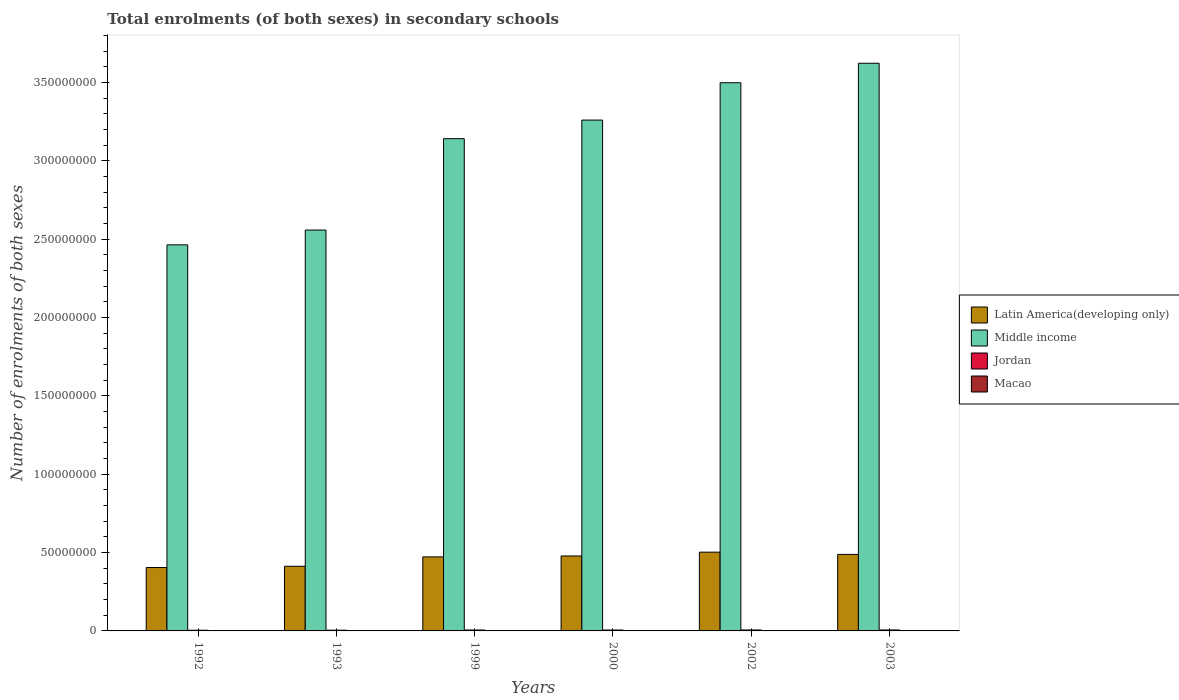How many different coloured bars are there?
Your response must be concise. 4. How many groups of bars are there?
Give a very brief answer. 6. Are the number of bars on each tick of the X-axis equal?
Make the answer very short. Yes. How many bars are there on the 2nd tick from the left?
Keep it short and to the point. 4. How many bars are there on the 4th tick from the right?
Ensure brevity in your answer.  4. In how many cases, is the number of bars for a given year not equal to the number of legend labels?
Make the answer very short. 0. What is the number of enrolments in secondary schools in Jordan in 1992?
Your answer should be very brief. 4.39e+05. Across all years, what is the maximum number of enrolments in secondary schools in Jordan?
Provide a succinct answer. 6.13e+05. Across all years, what is the minimum number of enrolments in secondary schools in Latin America(developing only)?
Offer a very short reply. 4.04e+07. What is the total number of enrolments in secondary schools in Latin America(developing only) in the graph?
Provide a succinct answer. 2.76e+08. What is the difference between the number of enrolments in secondary schools in Jordan in 1999 and that in 2002?
Provide a short and direct response. -2.72e+04. What is the difference between the number of enrolments in secondary schools in Latin America(developing only) in 1993 and the number of enrolments in secondary schools in Middle income in 2002?
Make the answer very short. -3.09e+08. What is the average number of enrolments in secondary schools in Macao per year?
Give a very brief answer. 3.22e+04. In the year 1992, what is the difference between the number of enrolments in secondary schools in Macao and number of enrolments in secondary schools in Middle income?
Offer a very short reply. -2.46e+08. In how many years, is the number of enrolments in secondary schools in Latin America(developing only) greater than 340000000?
Your answer should be compact. 0. What is the ratio of the number of enrolments in secondary schools in Macao in 1992 to that in 2002?
Your answer should be compact. 0.45. What is the difference between the highest and the second highest number of enrolments in secondary schools in Jordan?
Your answer should be compact. 6505. What is the difference between the highest and the lowest number of enrolments in secondary schools in Jordan?
Offer a very short reply. 1.74e+05. What does the 2nd bar from the left in 1999 represents?
Make the answer very short. Middle income. What does the 4th bar from the right in 1992 represents?
Keep it short and to the point. Latin America(developing only). Is it the case that in every year, the sum of the number of enrolments in secondary schools in Middle income and number of enrolments in secondary schools in Latin America(developing only) is greater than the number of enrolments in secondary schools in Macao?
Ensure brevity in your answer.  Yes. How many bars are there?
Provide a succinct answer. 24. Are all the bars in the graph horizontal?
Your answer should be compact. No. Where does the legend appear in the graph?
Offer a terse response. Center right. How many legend labels are there?
Give a very brief answer. 4. How are the legend labels stacked?
Keep it short and to the point. Vertical. What is the title of the graph?
Offer a very short reply. Total enrolments (of both sexes) in secondary schools. What is the label or title of the X-axis?
Provide a short and direct response. Years. What is the label or title of the Y-axis?
Your answer should be compact. Number of enrolments of both sexes. What is the Number of enrolments of both sexes of Latin America(developing only) in 1992?
Make the answer very short. 4.04e+07. What is the Number of enrolments of both sexes of Middle income in 1992?
Keep it short and to the point. 2.46e+08. What is the Number of enrolments of both sexes in Jordan in 1992?
Offer a terse response. 4.39e+05. What is the Number of enrolments of both sexes of Macao in 1992?
Your answer should be very brief. 1.90e+04. What is the Number of enrolments of both sexes in Latin America(developing only) in 1993?
Offer a very short reply. 4.13e+07. What is the Number of enrolments of both sexes in Middle income in 1993?
Keep it short and to the point. 2.56e+08. What is the Number of enrolments of both sexes in Jordan in 1993?
Offer a very short reply. 4.58e+05. What is the Number of enrolments of both sexes in Macao in 1993?
Your answer should be compact. 2.04e+04. What is the Number of enrolments of both sexes of Latin America(developing only) in 1999?
Keep it short and to the point. 4.72e+07. What is the Number of enrolments of both sexes in Middle income in 1999?
Your answer should be very brief. 3.14e+08. What is the Number of enrolments of both sexes in Jordan in 1999?
Your response must be concise. 5.79e+05. What is the Number of enrolments of both sexes in Macao in 1999?
Provide a short and direct response. 3.19e+04. What is the Number of enrolments of both sexes of Latin America(developing only) in 2000?
Ensure brevity in your answer.  4.78e+07. What is the Number of enrolments of both sexes of Middle income in 2000?
Your response must be concise. 3.26e+08. What is the Number of enrolments of both sexes in Jordan in 2000?
Make the answer very short. 5.84e+05. What is the Number of enrolments of both sexes in Macao in 2000?
Keep it short and to the point. 3.54e+04. What is the Number of enrolments of both sexes of Latin America(developing only) in 2002?
Ensure brevity in your answer.  5.03e+07. What is the Number of enrolments of both sexes in Middle income in 2002?
Offer a very short reply. 3.50e+08. What is the Number of enrolments of both sexes of Jordan in 2002?
Provide a succinct answer. 6.07e+05. What is the Number of enrolments of both sexes of Macao in 2002?
Provide a succinct answer. 4.20e+04. What is the Number of enrolments of both sexes of Latin America(developing only) in 2003?
Make the answer very short. 4.88e+07. What is the Number of enrolments of both sexes of Middle income in 2003?
Your response must be concise. 3.62e+08. What is the Number of enrolments of both sexes in Jordan in 2003?
Ensure brevity in your answer.  6.13e+05. What is the Number of enrolments of both sexes in Macao in 2003?
Offer a terse response. 4.44e+04. Across all years, what is the maximum Number of enrolments of both sexes of Latin America(developing only)?
Offer a very short reply. 5.03e+07. Across all years, what is the maximum Number of enrolments of both sexes of Middle income?
Your response must be concise. 3.62e+08. Across all years, what is the maximum Number of enrolments of both sexes in Jordan?
Offer a terse response. 6.13e+05. Across all years, what is the maximum Number of enrolments of both sexes in Macao?
Ensure brevity in your answer.  4.44e+04. Across all years, what is the minimum Number of enrolments of both sexes of Latin America(developing only)?
Keep it short and to the point. 4.04e+07. Across all years, what is the minimum Number of enrolments of both sexes in Middle income?
Keep it short and to the point. 2.46e+08. Across all years, what is the minimum Number of enrolments of both sexes in Jordan?
Offer a terse response. 4.39e+05. Across all years, what is the minimum Number of enrolments of both sexes of Macao?
Your answer should be compact. 1.90e+04. What is the total Number of enrolments of both sexes of Latin America(developing only) in the graph?
Give a very brief answer. 2.76e+08. What is the total Number of enrolments of both sexes in Middle income in the graph?
Offer a terse response. 1.85e+09. What is the total Number of enrolments of both sexes of Jordan in the graph?
Ensure brevity in your answer.  3.28e+06. What is the total Number of enrolments of both sexes of Macao in the graph?
Offer a very short reply. 1.93e+05. What is the difference between the Number of enrolments of both sexes in Latin America(developing only) in 1992 and that in 1993?
Your response must be concise. -8.00e+05. What is the difference between the Number of enrolments of both sexes of Middle income in 1992 and that in 1993?
Provide a short and direct response. -9.45e+06. What is the difference between the Number of enrolments of both sexes in Jordan in 1992 and that in 1993?
Your response must be concise. -1.95e+04. What is the difference between the Number of enrolments of both sexes of Macao in 1992 and that in 1993?
Your answer should be compact. -1405. What is the difference between the Number of enrolments of both sexes of Latin America(developing only) in 1992 and that in 1999?
Ensure brevity in your answer.  -6.79e+06. What is the difference between the Number of enrolments of both sexes of Middle income in 1992 and that in 1999?
Ensure brevity in your answer.  -6.78e+07. What is the difference between the Number of enrolments of both sexes in Jordan in 1992 and that in 1999?
Offer a very short reply. -1.41e+05. What is the difference between the Number of enrolments of both sexes in Macao in 1992 and that in 1999?
Offer a terse response. -1.29e+04. What is the difference between the Number of enrolments of both sexes of Latin America(developing only) in 1992 and that in 2000?
Offer a terse response. -7.37e+06. What is the difference between the Number of enrolments of both sexes in Middle income in 1992 and that in 2000?
Your answer should be very brief. -7.96e+07. What is the difference between the Number of enrolments of both sexes of Jordan in 1992 and that in 2000?
Keep it short and to the point. -1.45e+05. What is the difference between the Number of enrolments of both sexes in Macao in 1992 and that in 2000?
Your answer should be very brief. -1.64e+04. What is the difference between the Number of enrolments of both sexes of Latin America(developing only) in 1992 and that in 2002?
Offer a terse response. -9.80e+06. What is the difference between the Number of enrolments of both sexes of Middle income in 1992 and that in 2002?
Your answer should be compact. -1.03e+08. What is the difference between the Number of enrolments of both sexes of Jordan in 1992 and that in 2002?
Your answer should be very brief. -1.68e+05. What is the difference between the Number of enrolments of both sexes of Macao in 1992 and that in 2002?
Keep it short and to the point. -2.30e+04. What is the difference between the Number of enrolments of both sexes of Latin America(developing only) in 1992 and that in 2003?
Make the answer very short. -8.37e+06. What is the difference between the Number of enrolments of both sexes in Middle income in 1992 and that in 2003?
Ensure brevity in your answer.  -1.16e+08. What is the difference between the Number of enrolments of both sexes of Jordan in 1992 and that in 2003?
Provide a succinct answer. -1.74e+05. What is the difference between the Number of enrolments of both sexes in Macao in 1992 and that in 2003?
Ensure brevity in your answer.  -2.54e+04. What is the difference between the Number of enrolments of both sexes in Latin America(developing only) in 1993 and that in 1999?
Offer a very short reply. -5.99e+06. What is the difference between the Number of enrolments of both sexes in Middle income in 1993 and that in 1999?
Provide a short and direct response. -5.83e+07. What is the difference between the Number of enrolments of both sexes in Jordan in 1993 and that in 1999?
Your answer should be compact. -1.21e+05. What is the difference between the Number of enrolments of both sexes in Macao in 1993 and that in 1999?
Your answer should be very brief. -1.15e+04. What is the difference between the Number of enrolments of both sexes in Latin America(developing only) in 1993 and that in 2000?
Make the answer very short. -6.57e+06. What is the difference between the Number of enrolments of both sexes in Middle income in 1993 and that in 2000?
Your answer should be very brief. -7.02e+07. What is the difference between the Number of enrolments of both sexes of Jordan in 1993 and that in 2000?
Offer a very short reply. -1.25e+05. What is the difference between the Number of enrolments of both sexes of Macao in 1993 and that in 2000?
Provide a short and direct response. -1.50e+04. What is the difference between the Number of enrolments of both sexes in Latin America(developing only) in 1993 and that in 2002?
Offer a terse response. -9.00e+06. What is the difference between the Number of enrolments of both sexes of Middle income in 1993 and that in 2002?
Offer a very short reply. -9.40e+07. What is the difference between the Number of enrolments of both sexes in Jordan in 1993 and that in 2002?
Offer a terse response. -1.48e+05. What is the difference between the Number of enrolments of both sexes in Macao in 1993 and that in 2002?
Your answer should be compact. -2.16e+04. What is the difference between the Number of enrolments of both sexes of Latin America(developing only) in 1993 and that in 2003?
Keep it short and to the point. -7.57e+06. What is the difference between the Number of enrolments of both sexes in Middle income in 1993 and that in 2003?
Provide a short and direct response. -1.06e+08. What is the difference between the Number of enrolments of both sexes of Jordan in 1993 and that in 2003?
Give a very brief answer. -1.55e+05. What is the difference between the Number of enrolments of both sexes in Macao in 1993 and that in 2003?
Your answer should be compact. -2.40e+04. What is the difference between the Number of enrolments of both sexes in Latin America(developing only) in 1999 and that in 2000?
Ensure brevity in your answer.  -5.86e+05. What is the difference between the Number of enrolments of both sexes in Middle income in 1999 and that in 2000?
Ensure brevity in your answer.  -1.19e+07. What is the difference between the Number of enrolments of both sexes of Jordan in 1999 and that in 2000?
Your answer should be compact. -4090. What is the difference between the Number of enrolments of both sexes in Macao in 1999 and that in 2000?
Give a very brief answer. -3508. What is the difference between the Number of enrolments of both sexes of Latin America(developing only) in 1999 and that in 2002?
Offer a terse response. -3.01e+06. What is the difference between the Number of enrolments of both sexes in Middle income in 1999 and that in 2002?
Your answer should be compact. -3.57e+07. What is the difference between the Number of enrolments of both sexes of Jordan in 1999 and that in 2002?
Make the answer very short. -2.72e+04. What is the difference between the Number of enrolments of both sexes in Macao in 1999 and that in 2002?
Your response must be concise. -1.02e+04. What is the difference between the Number of enrolments of both sexes of Latin America(developing only) in 1999 and that in 2003?
Your answer should be very brief. -1.58e+06. What is the difference between the Number of enrolments of both sexes in Middle income in 1999 and that in 2003?
Give a very brief answer. -4.81e+07. What is the difference between the Number of enrolments of both sexes in Jordan in 1999 and that in 2003?
Ensure brevity in your answer.  -3.37e+04. What is the difference between the Number of enrolments of both sexes of Macao in 1999 and that in 2003?
Provide a short and direct response. -1.26e+04. What is the difference between the Number of enrolments of both sexes of Latin America(developing only) in 2000 and that in 2002?
Your answer should be very brief. -2.43e+06. What is the difference between the Number of enrolments of both sexes of Middle income in 2000 and that in 2002?
Your answer should be very brief. -2.38e+07. What is the difference between the Number of enrolments of both sexes of Jordan in 2000 and that in 2002?
Ensure brevity in your answer.  -2.31e+04. What is the difference between the Number of enrolments of both sexes in Macao in 2000 and that in 2002?
Your answer should be very brief. -6650. What is the difference between the Number of enrolments of both sexes of Latin America(developing only) in 2000 and that in 2003?
Offer a terse response. -9.97e+05. What is the difference between the Number of enrolments of both sexes of Middle income in 2000 and that in 2003?
Provide a short and direct response. -3.62e+07. What is the difference between the Number of enrolments of both sexes in Jordan in 2000 and that in 2003?
Offer a very short reply. -2.96e+04. What is the difference between the Number of enrolments of both sexes in Macao in 2000 and that in 2003?
Your answer should be compact. -9058. What is the difference between the Number of enrolments of both sexes of Latin America(developing only) in 2002 and that in 2003?
Your response must be concise. 1.43e+06. What is the difference between the Number of enrolments of both sexes in Middle income in 2002 and that in 2003?
Give a very brief answer. -1.24e+07. What is the difference between the Number of enrolments of both sexes of Jordan in 2002 and that in 2003?
Provide a short and direct response. -6505. What is the difference between the Number of enrolments of both sexes in Macao in 2002 and that in 2003?
Offer a very short reply. -2408. What is the difference between the Number of enrolments of both sexes in Latin America(developing only) in 1992 and the Number of enrolments of both sexes in Middle income in 1993?
Provide a short and direct response. -2.15e+08. What is the difference between the Number of enrolments of both sexes of Latin America(developing only) in 1992 and the Number of enrolments of both sexes of Jordan in 1993?
Keep it short and to the point. 4.00e+07. What is the difference between the Number of enrolments of both sexes of Latin America(developing only) in 1992 and the Number of enrolments of both sexes of Macao in 1993?
Make the answer very short. 4.04e+07. What is the difference between the Number of enrolments of both sexes in Middle income in 1992 and the Number of enrolments of both sexes in Jordan in 1993?
Offer a very short reply. 2.46e+08. What is the difference between the Number of enrolments of both sexes in Middle income in 1992 and the Number of enrolments of both sexes in Macao in 1993?
Make the answer very short. 2.46e+08. What is the difference between the Number of enrolments of both sexes in Jordan in 1992 and the Number of enrolments of both sexes in Macao in 1993?
Your answer should be compact. 4.19e+05. What is the difference between the Number of enrolments of both sexes in Latin America(developing only) in 1992 and the Number of enrolments of both sexes in Middle income in 1999?
Your answer should be compact. -2.74e+08. What is the difference between the Number of enrolments of both sexes of Latin America(developing only) in 1992 and the Number of enrolments of both sexes of Jordan in 1999?
Your answer should be compact. 3.99e+07. What is the difference between the Number of enrolments of both sexes in Latin America(developing only) in 1992 and the Number of enrolments of both sexes in Macao in 1999?
Ensure brevity in your answer.  4.04e+07. What is the difference between the Number of enrolments of both sexes in Middle income in 1992 and the Number of enrolments of both sexes in Jordan in 1999?
Ensure brevity in your answer.  2.46e+08. What is the difference between the Number of enrolments of both sexes in Middle income in 1992 and the Number of enrolments of both sexes in Macao in 1999?
Your response must be concise. 2.46e+08. What is the difference between the Number of enrolments of both sexes in Jordan in 1992 and the Number of enrolments of both sexes in Macao in 1999?
Make the answer very short. 4.07e+05. What is the difference between the Number of enrolments of both sexes of Latin America(developing only) in 1992 and the Number of enrolments of both sexes of Middle income in 2000?
Make the answer very short. -2.85e+08. What is the difference between the Number of enrolments of both sexes of Latin America(developing only) in 1992 and the Number of enrolments of both sexes of Jordan in 2000?
Ensure brevity in your answer.  3.99e+07. What is the difference between the Number of enrolments of both sexes of Latin America(developing only) in 1992 and the Number of enrolments of both sexes of Macao in 2000?
Make the answer very short. 4.04e+07. What is the difference between the Number of enrolments of both sexes in Middle income in 1992 and the Number of enrolments of both sexes in Jordan in 2000?
Keep it short and to the point. 2.46e+08. What is the difference between the Number of enrolments of both sexes in Middle income in 1992 and the Number of enrolments of both sexes in Macao in 2000?
Make the answer very short. 2.46e+08. What is the difference between the Number of enrolments of both sexes in Jordan in 1992 and the Number of enrolments of both sexes in Macao in 2000?
Give a very brief answer. 4.04e+05. What is the difference between the Number of enrolments of both sexes of Latin America(developing only) in 1992 and the Number of enrolments of both sexes of Middle income in 2002?
Your answer should be very brief. -3.09e+08. What is the difference between the Number of enrolments of both sexes of Latin America(developing only) in 1992 and the Number of enrolments of both sexes of Jordan in 2002?
Your answer should be compact. 3.98e+07. What is the difference between the Number of enrolments of both sexes in Latin America(developing only) in 1992 and the Number of enrolments of both sexes in Macao in 2002?
Provide a short and direct response. 4.04e+07. What is the difference between the Number of enrolments of both sexes of Middle income in 1992 and the Number of enrolments of both sexes of Jordan in 2002?
Make the answer very short. 2.46e+08. What is the difference between the Number of enrolments of both sexes in Middle income in 1992 and the Number of enrolments of both sexes in Macao in 2002?
Keep it short and to the point. 2.46e+08. What is the difference between the Number of enrolments of both sexes in Jordan in 1992 and the Number of enrolments of both sexes in Macao in 2002?
Offer a terse response. 3.97e+05. What is the difference between the Number of enrolments of both sexes of Latin America(developing only) in 1992 and the Number of enrolments of both sexes of Middle income in 2003?
Keep it short and to the point. -3.22e+08. What is the difference between the Number of enrolments of both sexes in Latin America(developing only) in 1992 and the Number of enrolments of both sexes in Jordan in 2003?
Your answer should be very brief. 3.98e+07. What is the difference between the Number of enrolments of both sexes in Latin America(developing only) in 1992 and the Number of enrolments of both sexes in Macao in 2003?
Your answer should be compact. 4.04e+07. What is the difference between the Number of enrolments of both sexes in Middle income in 1992 and the Number of enrolments of both sexes in Jordan in 2003?
Your answer should be very brief. 2.46e+08. What is the difference between the Number of enrolments of both sexes in Middle income in 1992 and the Number of enrolments of both sexes in Macao in 2003?
Offer a very short reply. 2.46e+08. What is the difference between the Number of enrolments of both sexes of Jordan in 1992 and the Number of enrolments of both sexes of Macao in 2003?
Offer a very short reply. 3.94e+05. What is the difference between the Number of enrolments of both sexes in Latin America(developing only) in 1993 and the Number of enrolments of both sexes in Middle income in 1999?
Your response must be concise. -2.73e+08. What is the difference between the Number of enrolments of both sexes of Latin America(developing only) in 1993 and the Number of enrolments of both sexes of Jordan in 1999?
Give a very brief answer. 4.07e+07. What is the difference between the Number of enrolments of both sexes in Latin America(developing only) in 1993 and the Number of enrolments of both sexes in Macao in 1999?
Provide a succinct answer. 4.12e+07. What is the difference between the Number of enrolments of both sexes in Middle income in 1993 and the Number of enrolments of both sexes in Jordan in 1999?
Your answer should be compact. 2.55e+08. What is the difference between the Number of enrolments of both sexes of Middle income in 1993 and the Number of enrolments of both sexes of Macao in 1999?
Ensure brevity in your answer.  2.56e+08. What is the difference between the Number of enrolments of both sexes of Jordan in 1993 and the Number of enrolments of both sexes of Macao in 1999?
Offer a terse response. 4.27e+05. What is the difference between the Number of enrolments of both sexes of Latin America(developing only) in 1993 and the Number of enrolments of both sexes of Middle income in 2000?
Give a very brief answer. -2.85e+08. What is the difference between the Number of enrolments of both sexes in Latin America(developing only) in 1993 and the Number of enrolments of both sexes in Jordan in 2000?
Your response must be concise. 4.07e+07. What is the difference between the Number of enrolments of both sexes of Latin America(developing only) in 1993 and the Number of enrolments of both sexes of Macao in 2000?
Your answer should be very brief. 4.12e+07. What is the difference between the Number of enrolments of both sexes of Middle income in 1993 and the Number of enrolments of both sexes of Jordan in 2000?
Give a very brief answer. 2.55e+08. What is the difference between the Number of enrolments of both sexes of Middle income in 1993 and the Number of enrolments of both sexes of Macao in 2000?
Keep it short and to the point. 2.56e+08. What is the difference between the Number of enrolments of both sexes of Jordan in 1993 and the Number of enrolments of both sexes of Macao in 2000?
Provide a succinct answer. 4.23e+05. What is the difference between the Number of enrolments of both sexes of Latin America(developing only) in 1993 and the Number of enrolments of both sexes of Middle income in 2002?
Offer a terse response. -3.09e+08. What is the difference between the Number of enrolments of both sexes in Latin America(developing only) in 1993 and the Number of enrolments of both sexes in Jordan in 2002?
Provide a short and direct response. 4.06e+07. What is the difference between the Number of enrolments of both sexes in Latin America(developing only) in 1993 and the Number of enrolments of both sexes in Macao in 2002?
Give a very brief answer. 4.12e+07. What is the difference between the Number of enrolments of both sexes of Middle income in 1993 and the Number of enrolments of both sexes of Jordan in 2002?
Your answer should be very brief. 2.55e+08. What is the difference between the Number of enrolments of both sexes of Middle income in 1993 and the Number of enrolments of both sexes of Macao in 2002?
Offer a terse response. 2.56e+08. What is the difference between the Number of enrolments of both sexes of Jordan in 1993 and the Number of enrolments of both sexes of Macao in 2002?
Keep it short and to the point. 4.16e+05. What is the difference between the Number of enrolments of both sexes of Latin America(developing only) in 1993 and the Number of enrolments of both sexes of Middle income in 2003?
Ensure brevity in your answer.  -3.21e+08. What is the difference between the Number of enrolments of both sexes in Latin America(developing only) in 1993 and the Number of enrolments of both sexes in Jordan in 2003?
Offer a terse response. 4.06e+07. What is the difference between the Number of enrolments of both sexes of Latin America(developing only) in 1993 and the Number of enrolments of both sexes of Macao in 2003?
Provide a succinct answer. 4.12e+07. What is the difference between the Number of enrolments of both sexes in Middle income in 1993 and the Number of enrolments of both sexes in Jordan in 2003?
Keep it short and to the point. 2.55e+08. What is the difference between the Number of enrolments of both sexes in Middle income in 1993 and the Number of enrolments of both sexes in Macao in 2003?
Offer a terse response. 2.56e+08. What is the difference between the Number of enrolments of both sexes in Jordan in 1993 and the Number of enrolments of both sexes in Macao in 2003?
Your response must be concise. 4.14e+05. What is the difference between the Number of enrolments of both sexes in Latin America(developing only) in 1999 and the Number of enrolments of both sexes in Middle income in 2000?
Ensure brevity in your answer.  -2.79e+08. What is the difference between the Number of enrolments of both sexes of Latin America(developing only) in 1999 and the Number of enrolments of both sexes of Jordan in 2000?
Your response must be concise. 4.67e+07. What is the difference between the Number of enrolments of both sexes of Latin America(developing only) in 1999 and the Number of enrolments of both sexes of Macao in 2000?
Ensure brevity in your answer.  4.72e+07. What is the difference between the Number of enrolments of both sexes of Middle income in 1999 and the Number of enrolments of both sexes of Jordan in 2000?
Offer a terse response. 3.13e+08. What is the difference between the Number of enrolments of both sexes in Middle income in 1999 and the Number of enrolments of both sexes in Macao in 2000?
Ensure brevity in your answer.  3.14e+08. What is the difference between the Number of enrolments of both sexes in Jordan in 1999 and the Number of enrolments of both sexes in Macao in 2000?
Your answer should be compact. 5.44e+05. What is the difference between the Number of enrolments of both sexes of Latin America(developing only) in 1999 and the Number of enrolments of both sexes of Middle income in 2002?
Give a very brief answer. -3.03e+08. What is the difference between the Number of enrolments of both sexes in Latin America(developing only) in 1999 and the Number of enrolments of both sexes in Jordan in 2002?
Your response must be concise. 4.66e+07. What is the difference between the Number of enrolments of both sexes of Latin America(developing only) in 1999 and the Number of enrolments of both sexes of Macao in 2002?
Offer a very short reply. 4.72e+07. What is the difference between the Number of enrolments of both sexes of Middle income in 1999 and the Number of enrolments of both sexes of Jordan in 2002?
Ensure brevity in your answer.  3.13e+08. What is the difference between the Number of enrolments of both sexes in Middle income in 1999 and the Number of enrolments of both sexes in Macao in 2002?
Offer a terse response. 3.14e+08. What is the difference between the Number of enrolments of both sexes in Jordan in 1999 and the Number of enrolments of both sexes in Macao in 2002?
Your answer should be very brief. 5.37e+05. What is the difference between the Number of enrolments of both sexes in Latin America(developing only) in 1999 and the Number of enrolments of both sexes in Middle income in 2003?
Your answer should be compact. -3.15e+08. What is the difference between the Number of enrolments of both sexes in Latin America(developing only) in 1999 and the Number of enrolments of both sexes in Jordan in 2003?
Keep it short and to the point. 4.66e+07. What is the difference between the Number of enrolments of both sexes in Latin America(developing only) in 1999 and the Number of enrolments of both sexes in Macao in 2003?
Make the answer very short. 4.72e+07. What is the difference between the Number of enrolments of both sexes in Middle income in 1999 and the Number of enrolments of both sexes in Jordan in 2003?
Make the answer very short. 3.13e+08. What is the difference between the Number of enrolments of both sexes of Middle income in 1999 and the Number of enrolments of both sexes of Macao in 2003?
Make the answer very short. 3.14e+08. What is the difference between the Number of enrolments of both sexes in Jordan in 1999 and the Number of enrolments of both sexes in Macao in 2003?
Provide a succinct answer. 5.35e+05. What is the difference between the Number of enrolments of both sexes in Latin America(developing only) in 2000 and the Number of enrolments of both sexes in Middle income in 2002?
Ensure brevity in your answer.  -3.02e+08. What is the difference between the Number of enrolments of both sexes in Latin America(developing only) in 2000 and the Number of enrolments of both sexes in Jordan in 2002?
Your response must be concise. 4.72e+07. What is the difference between the Number of enrolments of both sexes in Latin America(developing only) in 2000 and the Number of enrolments of both sexes in Macao in 2002?
Give a very brief answer. 4.78e+07. What is the difference between the Number of enrolments of both sexes in Middle income in 2000 and the Number of enrolments of both sexes in Jordan in 2002?
Give a very brief answer. 3.25e+08. What is the difference between the Number of enrolments of both sexes of Middle income in 2000 and the Number of enrolments of both sexes of Macao in 2002?
Your response must be concise. 3.26e+08. What is the difference between the Number of enrolments of both sexes of Jordan in 2000 and the Number of enrolments of both sexes of Macao in 2002?
Make the answer very short. 5.42e+05. What is the difference between the Number of enrolments of both sexes in Latin America(developing only) in 2000 and the Number of enrolments of both sexes in Middle income in 2003?
Your answer should be very brief. -3.14e+08. What is the difference between the Number of enrolments of both sexes of Latin America(developing only) in 2000 and the Number of enrolments of both sexes of Jordan in 2003?
Ensure brevity in your answer.  4.72e+07. What is the difference between the Number of enrolments of both sexes of Latin America(developing only) in 2000 and the Number of enrolments of both sexes of Macao in 2003?
Ensure brevity in your answer.  4.78e+07. What is the difference between the Number of enrolments of both sexes in Middle income in 2000 and the Number of enrolments of both sexes in Jordan in 2003?
Offer a very short reply. 3.25e+08. What is the difference between the Number of enrolments of both sexes in Middle income in 2000 and the Number of enrolments of both sexes in Macao in 2003?
Keep it short and to the point. 3.26e+08. What is the difference between the Number of enrolments of both sexes of Jordan in 2000 and the Number of enrolments of both sexes of Macao in 2003?
Provide a succinct answer. 5.39e+05. What is the difference between the Number of enrolments of both sexes in Latin America(developing only) in 2002 and the Number of enrolments of both sexes in Middle income in 2003?
Provide a succinct answer. -3.12e+08. What is the difference between the Number of enrolments of both sexes in Latin America(developing only) in 2002 and the Number of enrolments of both sexes in Jordan in 2003?
Your response must be concise. 4.96e+07. What is the difference between the Number of enrolments of both sexes of Latin America(developing only) in 2002 and the Number of enrolments of both sexes of Macao in 2003?
Keep it short and to the point. 5.02e+07. What is the difference between the Number of enrolments of both sexes of Middle income in 2002 and the Number of enrolments of both sexes of Jordan in 2003?
Provide a short and direct response. 3.49e+08. What is the difference between the Number of enrolments of both sexes of Middle income in 2002 and the Number of enrolments of both sexes of Macao in 2003?
Provide a short and direct response. 3.50e+08. What is the difference between the Number of enrolments of both sexes in Jordan in 2002 and the Number of enrolments of both sexes in Macao in 2003?
Ensure brevity in your answer.  5.62e+05. What is the average Number of enrolments of both sexes in Latin America(developing only) per year?
Your answer should be compact. 4.60e+07. What is the average Number of enrolments of both sexes of Middle income per year?
Give a very brief answer. 3.09e+08. What is the average Number of enrolments of both sexes in Jordan per year?
Offer a very short reply. 5.47e+05. What is the average Number of enrolments of both sexes of Macao per year?
Keep it short and to the point. 3.22e+04. In the year 1992, what is the difference between the Number of enrolments of both sexes in Latin America(developing only) and Number of enrolments of both sexes in Middle income?
Keep it short and to the point. -2.06e+08. In the year 1992, what is the difference between the Number of enrolments of both sexes of Latin America(developing only) and Number of enrolments of both sexes of Jordan?
Keep it short and to the point. 4.00e+07. In the year 1992, what is the difference between the Number of enrolments of both sexes in Latin America(developing only) and Number of enrolments of both sexes in Macao?
Keep it short and to the point. 4.04e+07. In the year 1992, what is the difference between the Number of enrolments of both sexes of Middle income and Number of enrolments of both sexes of Jordan?
Ensure brevity in your answer.  2.46e+08. In the year 1992, what is the difference between the Number of enrolments of both sexes of Middle income and Number of enrolments of both sexes of Macao?
Keep it short and to the point. 2.46e+08. In the year 1992, what is the difference between the Number of enrolments of both sexes in Jordan and Number of enrolments of both sexes in Macao?
Your answer should be compact. 4.20e+05. In the year 1993, what is the difference between the Number of enrolments of both sexes of Latin America(developing only) and Number of enrolments of both sexes of Middle income?
Make the answer very short. -2.15e+08. In the year 1993, what is the difference between the Number of enrolments of both sexes of Latin America(developing only) and Number of enrolments of both sexes of Jordan?
Your response must be concise. 4.08e+07. In the year 1993, what is the difference between the Number of enrolments of both sexes in Latin America(developing only) and Number of enrolments of both sexes in Macao?
Offer a terse response. 4.12e+07. In the year 1993, what is the difference between the Number of enrolments of both sexes of Middle income and Number of enrolments of both sexes of Jordan?
Offer a very short reply. 2.55e+08. In the year 1993, what is the difference between the Number of enrolments of both sexes in Middle income and Number of enrolments of both sexes in Macao?
Your response must be concise. 2.56e+08. In the year 1993, what is the difference between the Number of enrolments of both sexes in Jordan and Number of enrolments of both sexes in Macao?
Your answer should be very brief. 4.38e+05. In the year 1999, what is the difference between the Number of enrolments of both sexes in Latin America(developing only) and Number of enrolments of both sexes in Middle income?
Provide a succinct answer. -2.67e+08. In the year 1999, what is the difference between the Number of enrolments of both sexes in Latin America(developing only) and Number of enrolments of both sexes in Jordan?
Offer a terse response. 4.67e+07. In the year 1999, what is the difference between the Number of enrolments of both sexes of Latin America(developing only) and Number of enrolments of both sexes of Macao?
Keep it short and to the point. 4.72e+07. In the year 1999, what is the difference between the Number of enrolments of both sexes in Middle income and Number of enrolments of both sexes in Jordan?
Your response must be concise. 3.13e+08. In the year 1999, what is the difference between the Number of enrolments of both sexes of Middle income and Number of enrolments of both sexes of Macao?
Provide a succinct answer. 3.14e+08. In the year 1999, what is the difference between the Number of enrolments of both sexes of Jordan and Number of enrolments of both sexes of Macao?
Provide a succinct answer. 5.48e+05. In the year 2000, what is the difference between the Number of enrolments of both sexes of Latin America(developing only) and Number of enrolments of both sexes of Middle income?
Your response must be concise. -2.78e+08. In the year 2000, what is the difference between the Number of enrolments of both sexes in Latin America(developing only) and Number of enrolments of both sexes in Jordan?
Provide a succinct answer. 4.72e+07. In the year 2000, what is the difference between the Number of enrolments of both sexes of Latin America(developing only) and Number of enrolments of both sexes of Macao?
Offer a very short reply. 4.78e+07. In the year 2000, what is the difference between the Number of enrolments of both sexes of Middle income and Number of enrolments of both sexes of Jordan?
Keep it short and to the point. 3.25e+08. In the year 2000, what is the difference between the Number of enrolments of both sexes of Middle income and Number of enrolments of both sexes of Macao?
Your answer should be very brief. 3.26e+08. In the year 2000, what is the difference between the Number of enrolments of both sexes in Jordan and Number of enrolments of both sexes in Macao?
Offer a very short reply. 5.48e+05. In the year 2002, what is the difference between the Number of enrolments of both sexes in Latin America(developing only) and Number of enrolments of both sexes in Middle income?
Offer a terse response. -3.00e+08. In the year 2002, what is the difference between the Number of enrolments of both sexes of Latin America(developing only) and Number of enrolments of both sexes of Jordan?
Give a very brief answer. 4.96e+07. In the year 2002, what is the difference between the Number of enrolments of both sexes of Latin America(developing only) and Number of enrolments of both sexes of Macao?
Your response must be concise. 5.02e+07. In the year 2002, what is the difference between the Number of enrolments of both sexes in Middle income and Number of enrolments of both sexes in Jordan?
Offer a very short reply. 3.49e+08. In the year 2002, what is the difference between the Number of enrolments of both sexes of Middle income and Number of enrolments of both sexes of Macao?
Ensure brevity in your answer.  3.50e+08. In the year 2002, what is the difference between the Number of enrolments of both sexes of Jordan and Number of enrolments of both sexes of Macao?
Keep it short and to the point. 5.65e+05. In the year 2003, what is the difference between the Number of enrolments of both sexes of Latin America(developing only) and Number of enrolments of both sexes of Middle income?
Ensure brevity in your answer.  -3.13e+08. In the year 2003, what is the difference between the Number of enrolments of both sexes of Latin America(developing only) and Number of enrolments of both sexes of Jordan?
Ensure brevity in your answer.  4.82e+07. In the year 2003, what is the difference between the Number of enrolments of both sexes in Latin America(developing only) and Number of enrolments of both sexes in Macao?
Provide a succinct answer. 4.88e+07. In the year 2003, what is the difference between the Number of enrolments of both sexes of Middle income and Number of enrolments of both sexes of Jordan?
Make the answer very short. 3.62e+08. In the year 2003, what is the difference between the Number of enrolments of both sexes in Middle income and Number of enrolments of both sexes in Macao?
Offer a very short reply. 3.62e+08. In the year 2003, what is the difference between the Number of enrolments of both sexes of Jordan and Number of enrolments of both sexes of Macao?
Give a very brief answer. 5.69e+05. What is the ratio of the Number of enrolments of both sexes in Latin America(developing only) in 1992 to that in 1993?
Offer a terse response. 0.98. What is the ratio of the Number of enrolments of both sexes of Middle income in 1992 to that in 1993?
Your response must be concise. 0.96. What is the ratio of the Number of enrolments of both sexes in Jordan in 1992 to that in 1993?
Offer a very short reply. 0.96. What is the ratio of the Number of enrolments of both sexes in Macao in 1992 to that in 1993?
Provide a succinct answer. 0.93. What is the ratio of the Number of enrolments of both sexes of Latin America(developing only) in 1992 to that in 1999?
Make the answer very short. 0.86. What is the ratio of the Number of enrolments of both sexes in Middle income in 1992 to that in 1999?
Your answer should be compact. 0.78. What is the ratio of the Number of enrolments of both sexes in Jordan in 1992 to that in 1999?
Provide a succinct answer. 0.76. What is the ratio of the Number of enrolments of both sexes in Macao in 1992 to that in 1999?
Provide a succinct answer. 0.6. What is the ratio of the Number of enrolments of both sexes in Latin America(developing only) in 1992 to that in 2000?
Keep it short and to the point. 0.85. What is the ratio of the Number of enrolments of both sexes in Middle income in 1992 to that in 2000?
Your response must be concise. 0.76. What is the ratio of the Number of enrolments of both sexes of Jordan in 1992 to that in 2000?
Your answer should be compact. 0.75. What is the ratio of the Number of enrolments of both sexes in Macao in 1992 to that in 2000?
Give a very brief answer. 0.54. What is the ratio of the Number of enrolments of both sexes of Latin America(developing only) in 1992 to that in 2002?
Your response must be concise. 0.81. What is the ratio of the Number of enrolments of both sexes in Middle income in 1992 to that in 2002?
Your answer should be compact. 0.7. What is the ratio of the Number of enrolments of both sexes of Jordan in 1992 to that in 2002?
Your answer should be compact. 0.72. What is the ratio of the Number of enrolments of both sexes in Macao in 1992 to that in 2002?
Your answer should be compact. 0.45. What is the ratio of the Number of enrolments of both sexes in Latin America(developing only) in 1992 to that in 2003?
Offer a terse response. 0.83. What is the ratio of the Number of enrolments of both sexes in Middle income in 1992 to that in 2003?
Keep it short and to the point. 0.68. What is the ratio of the Number of enrolments of both sexes of Jordan in 1992 to that in 2003?
Keep it short and to the point. 0.72. What is the ratio of the Number of enrolments of both sexes of Macao in 1992 to that in 2003?
Provide a succinct answer. 0.43. What is the ratio of the Number of enrolments of both sexes in Latin America(developing only) in 1993 to that in 1999?
Offer a terse response. 0.87. What is the ratio of the Number of enrolments of both sexes in Middle income in 1993 to that in 1999?
Keep it short and to the point. 0.81. What is the ratio of the Number of enrolments of both sexes of Jordan in 1993 to that in 1999?
Provide a short and direct response. 0.79. What is the ratio of the Number of enrolments of both sexes in Macao in 1993 to that in 1999?
Keep it short and to the point. 0.64. What is the ratio of the Number of enrolments of both sexes of Latin America(developing only) in 1993 to that in 2000?
Your answer should be compact. 0.86. What is the ratio of the Number of enrolments of both sexes in Middle income in 1993 to that in 2000?
Your response must be concise. 0.78. What is the ratio of the Number of enrolments of both sexes of Jordan in 1993 to that in 2000?
Offer a very short reply. 0.79. What is the ratio of the Number of enrolments of both sexes of Macao in 1993 to that in 2000?
Your answer should be very brief. 0.58. What is the ratio of the Number of enrolments of both sexes in Latin America(developing only) in 1993 to that in 2002?
Keep it short and to the point. 0.82. What is the ratio of the Number of enrolments of both sexes in Middle income in 1993 to that in 2002?
Your answer should be compact. 0.73. What is the ratio of the Number of enrolments of both sexes in Jordan in 1993 to that in 2002?
Your response must be concise. 0.76. What is the ratio of the Number of enrolments of both sexes in Macao in 1993 to that in 2002?
Your answer should be compact. 0.49. What is the ratio of the Number of enrolments of both sexes of Latin America(developing only) in 1993 to that in 2003?
Provide a succinct answer. 0.84. What is the ratio of the Number of enrolments of both sexes of Middle income in 1993 to that in 2003?
Keep it short and to the point. 0.71. What is the ratio of the Number of enrolments of both sexes in Jordan in 1993 to that in 2003?
Offer a very short reply. 0.75. What is the ratio of the Number of enrolments of both sexes of Macao in 1993 to that in 2003?
Make the answer very short. 0.46. What is the ratio of the Number of enrolments of both sexes in Middle income in 1999 to that in 2000?
Keep it short and to the point. 0.96. What is the ratio of the Number of enrolments of both sexes in Macao in 1999 to that in 2000?
Your response must be concise. 0.9. What is the ratio of the Number of enrolments of both sexes of Middle income in 1999 to that in 2002?
Keep it short and to the point. 0.9. What is the ratio of the Number of enrolments of both sexes of Jordan in 1999 to that in 2002?
Make the answer very short. 0.96. What is the ratio of the Number of enrolments of both sexes in Macao in 1999 to that in 2002?
Ensure brevity in your answer.  0.76. What is the ratio of the Number of enrolments of both sexes of Latin America(developing only) in 1999 to that in 2003?
Make the answer very short. 0.97. What is the ratio of the Number of enrolments of both sexes in Middle income in 1999 to that in 2003?
Offer a very short reply. 0.87. What is the ratio of the Number of enrolments of both sexes in Jordan in 1999 to that in 2003?
Ensure brevity in your answer.  0.95. What is the ratio of the Number of enrolments of both sexes of Macao in 1999 to that in 2003?
Provide a short and direct response. 0.72. What is the ratio of the Number of enrolments of both sexes in Latin America(developing only) in 2000 to that in 2002?
Keep it short and to the point. 0.95. What is the ratio of the Number of enrolments of both sexes of Middle income in 2000 to that in 2002?
Offer a very short reply. 0.93. What is the ratio of the Number of enrolments of both sexes in Macao in 2000 to that in 2002?
Keep it short and to the point. 0.84. What is the ratio of the Number of enrolments of both sexes of Latin America(developing only) in 2000 to that in 2003?
Offer a very short reply. 0.98. What is the ratio of the Number of enrolments of both sexes of Middle income in 2000 to that in 2003?
Provide a succinct answer. 0.9. What is the ratio of the Number of enrolments of both sexes of Jordan in 2000 to that in 2003?
Make the answer very short. 0.95. What is the ratio of the Number of enrolments of both sexes in Macao in 2000 to that in 2003?
Offer a very short reply. 0.8. What is the ratio of the Number of enrolments of both sexes of Latin America(developing only) in 2002 to that in 2003?
Ensure brevity in your answer.  1.03. What is the ratio of the Number of enrolments of both sexes in Middle income in 2002 to that in 2003?
Your response must be concise. 0.97. What is the ratio of the Number of enrolments of both sexes of Jordan in 2002 to that in 2003?
Provide a succinct answer. 0.99. What is the ratio of the Number of enrolments of both sexes in Macao in 2002 to that in 2003?
Provide a succinct answer. 0.95. What is the difference between the highest and the second highest Number of enrolments of both sexes of Latin America(developing only)?
Ensure brevity in your answer.  1.43e+06. What is the difference between the highest and the second highest Number of enrolments of both sexes of Middle income?
Offer a terse response. 1.24e+07. What is the difference between the highest and the second highest Number of enrolments of both sexes of Jordan?
Your answer should be very brief. 6505. What is the difference between the highest and the second highest Number of enrolments of both sexes of Macao?
Ensure brevity in your answer.  2408. What is the difference between the highest and the lowest Number of enrolments of both sexes in Latin America(developing only)?
Your answer should be very brief. 9.80e+06. What is the difference between the highest and the lowest Number of enrolments of both sexes in Middle income?
Make the answer very short. 1.16e+08. What is the difference between the highest and the lowest Number of enrolments of both sexes of Jordan?
Ensure brevity in your answer.  1.74e+05. What is the difference between the highest and the lowest Number of enrolments of both sexes in Macao?
Provide a succinct answer. 2.54e+04. 